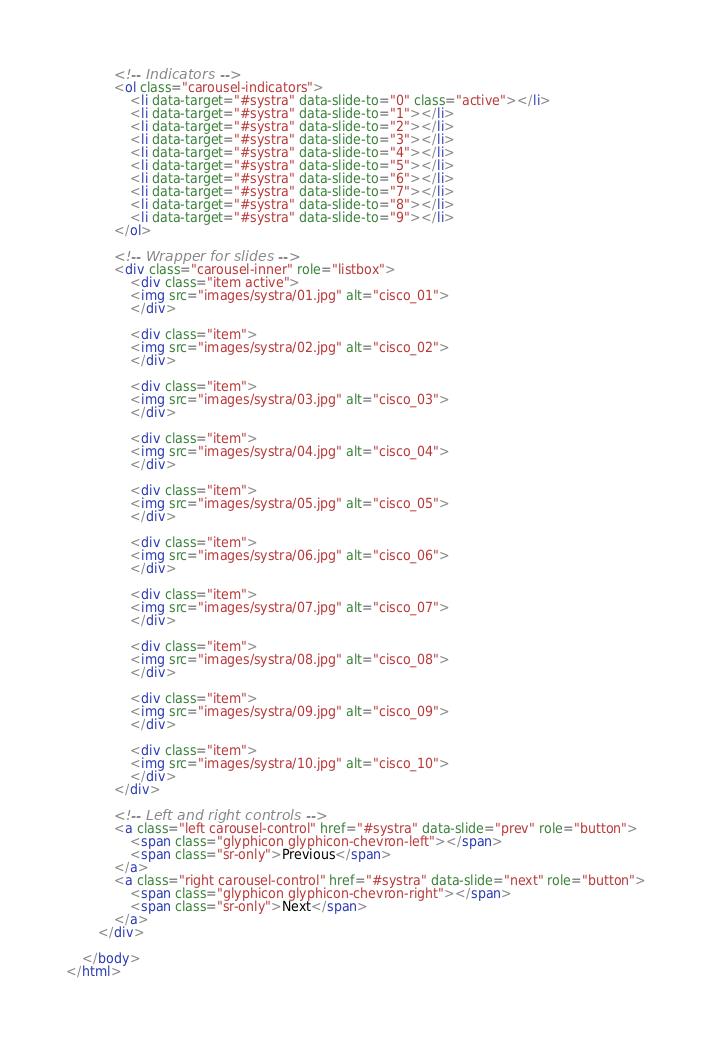Convert code to text. <code><loc_0><loc_0><loc_500><loc_500><_HTML_>            <!-- Indicators -->
            <ol class="carousel-indicators">
                <li data-target="#systra" data-slide-to="0" class="active"></li>
                <li data-target="#systra" data-slide-to="1"></li>
                <li data-target="#systra" data-slide-to="2"></li>
                <li data-target="#systra" data-slide-to="3"></li>
                <li data-target="#systra" data-slide-to="4"></li>
                <li data-target="#systra" data-slide-to="5"></li>
                <li data-target="#systra" data-slide-to="6"></li>
                <li data-target="#systra" data-slide-to="7"></li>
                <li data-target="#systra" data-slide-to="8"></li>
                <li data-target="#systra" data-slide-to="9"></li>
            </ol>

            <!-- Wrapper for slides -->
            <div class="carousel-inner" role="listbox">
                <div class="item active">
                <img src="images/systra/01.jpg" alt="cisco_01">
                </div>

                <div class="item">
                <img src="images/systra/02.jpg" alt="cisco_02">
                </div>

                <div class="item">
                <img src="images/systra/03.jpg" alt="cisco_03">
                </div>

                <div class="item">
                <img src="images/systra/04.jpg" alt="cisco_04">
                </div>

                <div class="item">
                <img src="images/systra/05.jpg" alt="cisco_05">
                </div>

                <div class="item">
                <img src="images/systra/06.jpg" alt="cisco_06">
                </div>

                <div class="item">
                <img src="images/systra/07.jpg" alt="cisco_07">
                </div>

                <div class="item">
                <img src="images/systra/08.jpg" alt="cisco_08">
                </div>

                <div class="item">
                <img src="images/systra/09.jpg" alt="cisco_09">
                </div>

                <div class="item">
                <img src="images/systra/10.jpg" alt="cisco_10">
                </div>
            </div>

            <!-- Left and right controls -->
            <a class="left carousel-control" href="#systra" data-slide="prev" role="button">
                <span class="glyphicon glyphicon-chevron-left"></span>
                <span class="sr-only">Previous</span>
            </a>
            <a class="right carousel-control" href="#systra" data-slide="next" role="button">
                <span class="glyphicon glyphicon-chevron-right"></span>
                <span class="sr-only">Next</span>
            </a>
        </div>
        
    </body>
</html></code> 